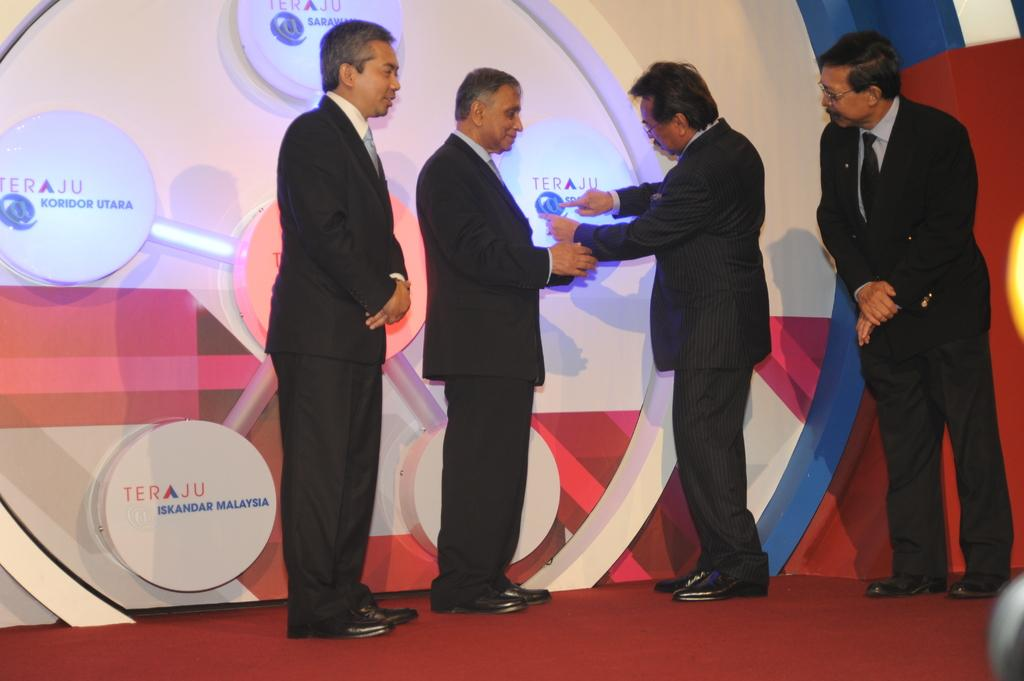How many people are present in the image? There are four people in the image. What are the people wearing? The people are wearing black suits. What is one person doing in the image? One person is pointing to a board. What can be seen in the background of the image? There is a wall in the background of the image. What is on the wall? There are lights on the wall. What is on the floor in the image? There is a carpet on the floor. What type of fairies can be seen flying around the people in the image? There are no fairies present in the image; it features four people wearing black suits and one person pointing to a board. What type of laborer is working on the carpet in the image? There is no laborer present in the image, and the carpet is not being worked on; it is simply a covering on the floor. 